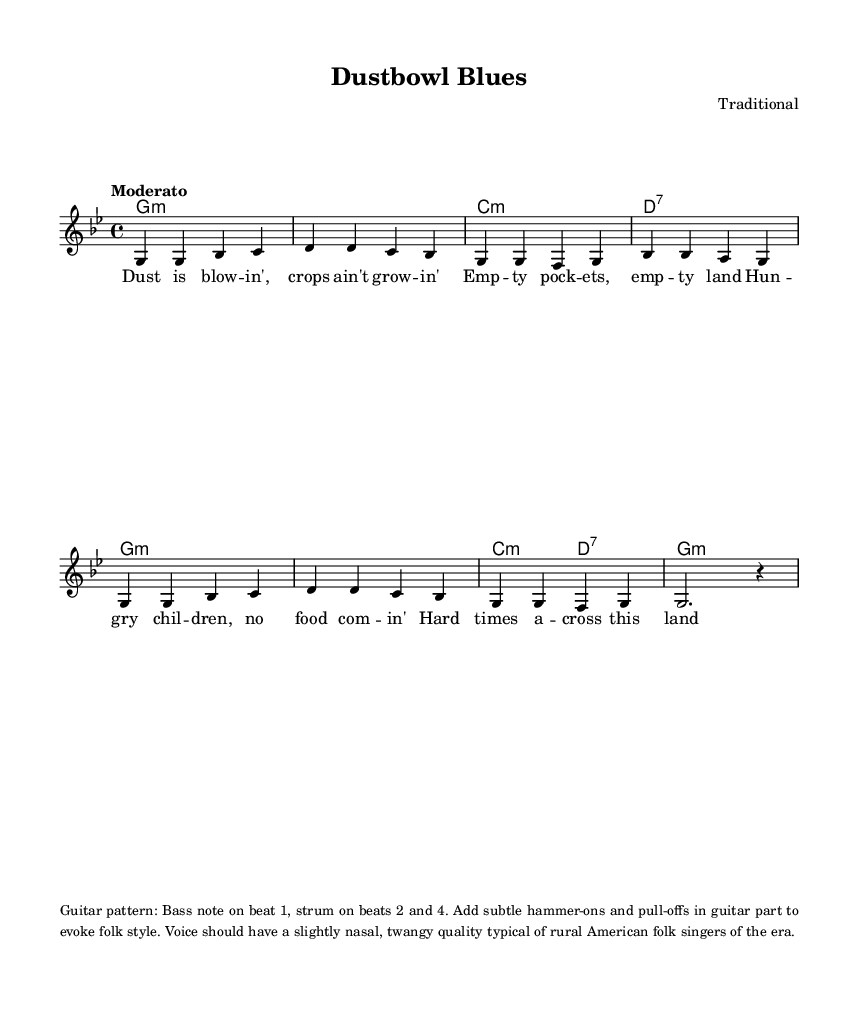What is the key signature of this music? The key signature is G minor, which has two flats (B♭ and E♭). This can be identified by looking at the key signature notation at the beginning of the staff.
Answer: G minor What is the time signature of this piece? The time signature is 4/4, which indicates there are four beats in each measure. This is displayed at the beginning of the sheet music after the key signature.
Answer: 4/4 What is the tempo indication given in the score? The tempo indication is "Moderato," which is written at the beginning of the score to suggest a moderate pace for the music.
Answer: Moderato How many verses are present in the lyric section? There is one verse in the lyric section. This can be confirmed by analyzing the lyric line, which contains four lines that correspond to the melody.
Answer: One What type of harmony is predominantly used in this song? The song predominantly uses minor harmonies. This can be determined by examining the chord symbols, which indicate minor chords like G minor, C minor, and others.
Answer: Minor What is the strumming pattern suggested for the guitar? The suggested strumming pattern is "Bass note on beat 1, strum on beats 2 and 4." This instruction is provided at the end of the sheet music, detailing how the guitar should be played.
Answer: Bass and strum What quality should the voice have according to the instructions? The voice should have a "slightly nasal, twangy quality." This quality is specified in the performance notes to reflect the style typical of rural American folk singers of the era.
Answer: Slightly nasal, twangy 